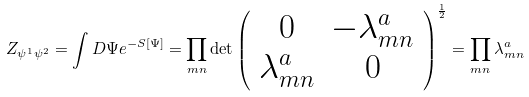Convert formula to latex. <formula><loc_0><loc_0><loc_500><loc_500>Z _ { \psi ^ { 1 } \psi ^ { 2 } } = \int D \Psi e ^ { - S [ \Psi ] } = \prod _ { m n } \det \left ( \begin{array} { c c c } 0 & - \lambda _ { m n } ^ { a } \\ \lambda _ { m n } ^ { a } & 0 \end{array} \right ) ^ { \frac { 1 } { 2 } } = \prod _ { m n } \lambda _ { m n } ^ { a }</formula> 